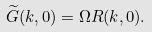<formula> <loc_0><loc_0><loc_500><loc_500>\widetilde { G } ( k , 0 ) = \Omega R ( k , 0 ) .</formula> 